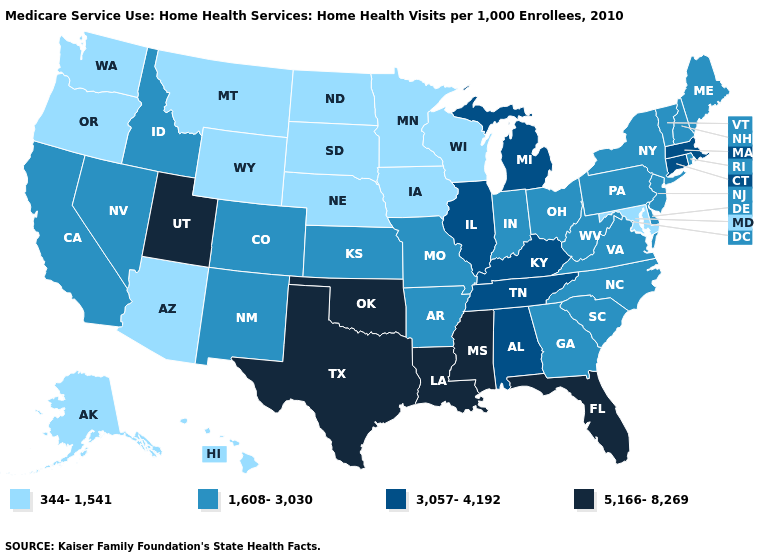What is the value of South Dakota?
Quick response, please. 344-1,541. What is the value of Mississippi?
Give a very brief answer. 5,166-8,269. What is the highest value in states that border Iowa?
Short answer required. 3,057-4,192. Name the states that have a value in the range 1,608-3,030?
Short answer required. Arkansas, California, Colorado, Delaware, Georgia, Idaho, Indiana, Kansas, Maine, Missouri, Nevada, New Hampshire, New Jersey, New Mexico, New York, North Carolina, Ohio, Pennsylvania, Rhode Island, South Carolina, Vermont, Virginia, West Virginia. What is the highest value in the West ?
Be succinct. 5,166-8,269. What is the highest value in the USA?
Be succinct. 5,166-8,269. What is the value of West Virginia?
Keep it brief. 1,608-3,030. Does the map have missing data?
Keep it brief. No. What is the highest value in the USA?
Quick response, please. 5,166-8,269. What is the highest value in the Northeast ?
Keep it brief. 3,057-4,192. Does Minnesota have the lowest value in the USA?
Short answer required. Yes. What is the lowest value in the Northeast?
Write a very short answer. 1,608-3,030. What is the value of New Jersey?
Concise answer only. 1,608-3,030. What is the value of New Hampshire?
Be succinct. 1,608-3,030. Which states hav the highest value in the West?
Concise answer only. Utah. 